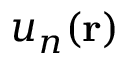<formula> <loc_0><loc_0><loc_500><loc_500>u _ { n } ( r )</formula> 